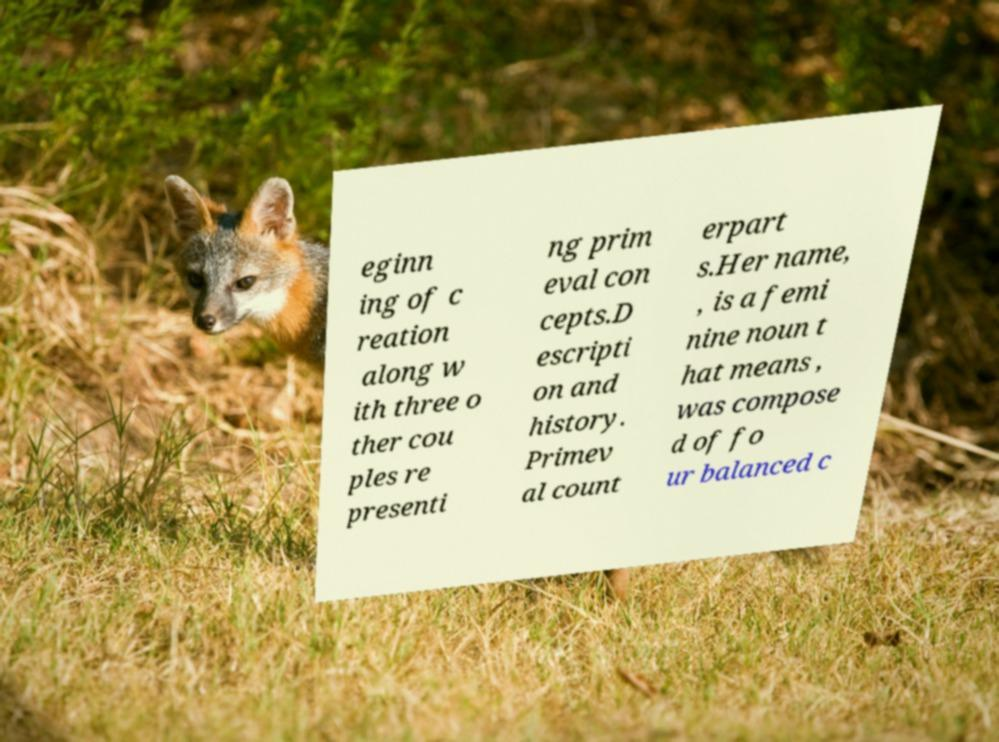Could you assist in decoding the text presented in this image and type it out clearly? eginn ing of c reation along w ith three o ther cou ples re presenti ng prim eval con cepts.D escripti on and history. Primev al count erpart s.Her name, , is a femi nine noun t hat means , was compose d of fo ur balanced c 